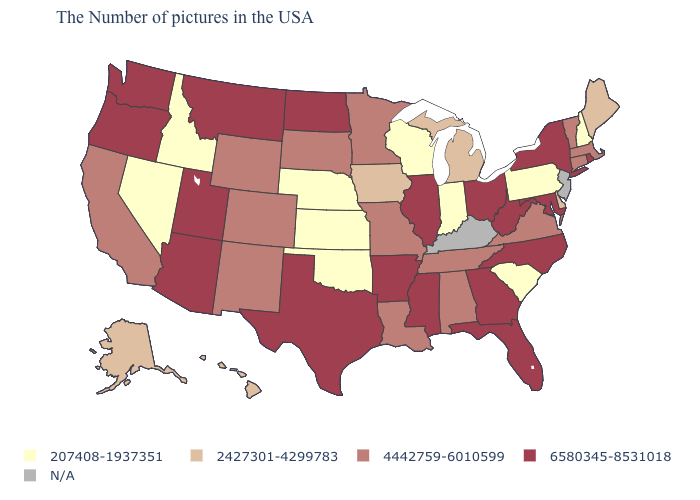Does South Carolina have the lowest value in the South?
Keep it brief. Yes. Among the states that border New Hampshire , does Maine have the lowest value?
Give a very brief answer. Yes. Among the states that border Arkansas , which have the lowest value?
Give a very brief answer. Oklahoma. What is the value of Delaware?
Concise answer only. 2427301-4299783. Name the states that have a value in the range 6580345-8531018?
Short answer required. Rhode Island, New York, Maryland, North Carolina, West Virginia, Ohio, Florida, Georgia, Illinois, Mississippi, Arkansas, Texas, North Dakota, Utah, Montana, Arizona, Washington, Oregon. Which states have the highest value in the USA?
Concise answer only. Rhode Island, New York, Maryland, North Carolina, West Virginia, Ohio, Florida, Georgia, Illinois, Mississippi, Arkansas, Texas, North Dakota, Utah, Montana, Arizona, Washington, Oregon. Name the states that have a value in the range 207408-1937351?
Be succinct. New Hampshire, Pennsylvania, South Carolina, Indiana, Wisconsin, Kansas, Nebraska, Oklahoma, Idaho, Nevada. Does the first symbol in the legend represent the smallest category?
Answer briefly. Yes. Name the states that have a value in the range 2427301-4299783?
Short answer required. Maine, Delaware, Michigan, Iowa, Alaska, Hawaii. Does Rhode Island have the highest value in the Northeast?
Short answer required. Yes. Name the states that have a value in the range 207408-1937351?
Answer briefly. New Hampshire, Pennsylvania, South Carolina, Indiana, Wisconsin, Kansas, Nebraska, Oklahoma, Idaho, Nevada. What is the value of Iowa?
Keep it brief. 2427301-4299783. Is the legend a continuous bar?
Keep it brief. No. 